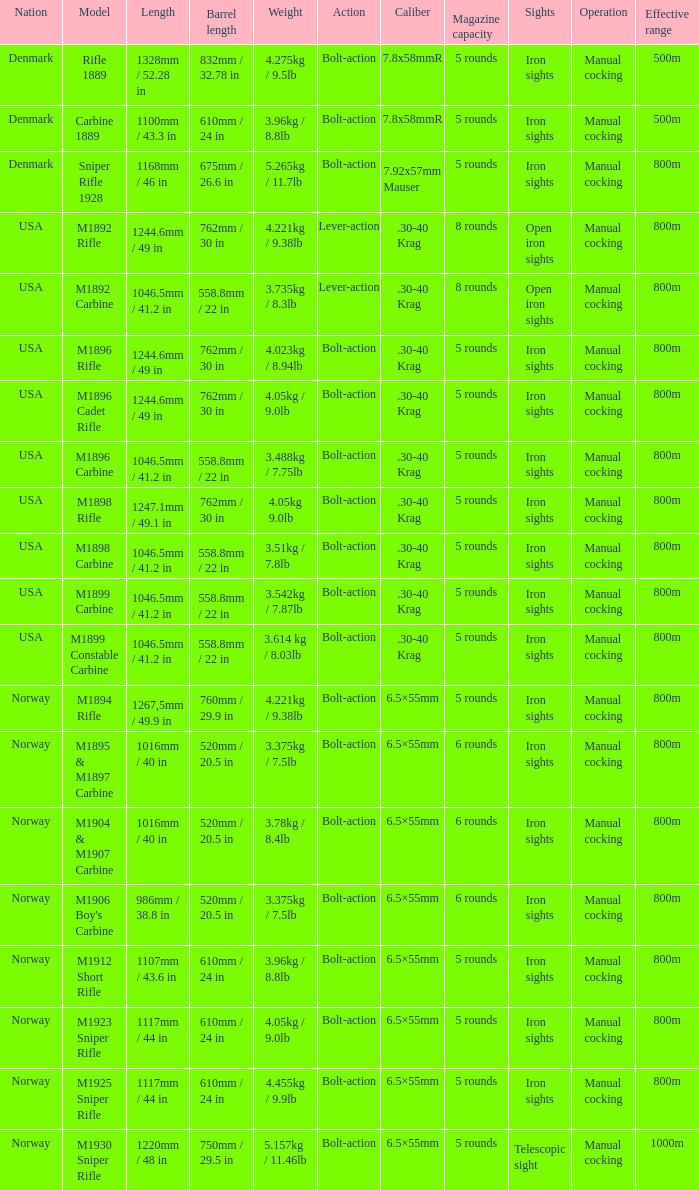What is Length, when Barrel Length is 750mm / 29.5 in? 1220mm / 48 in. 